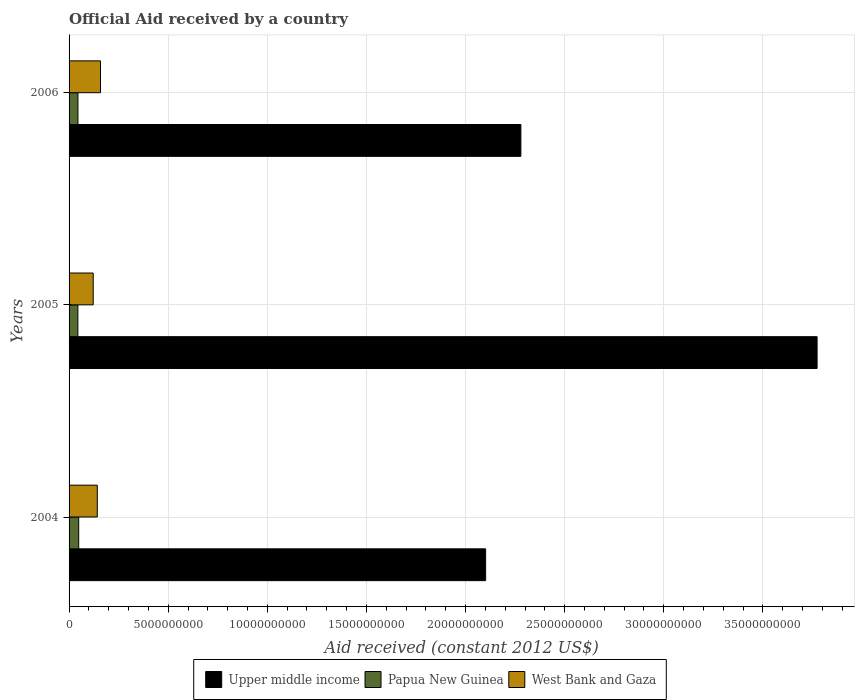How many groups of bars are there?
Your response must be concise. 3. Are the number of bars on each tick of the Y-axis equal?
Keep it short and to the point. Yes. How many bars are there on the 3rd tick from the bottom?
Ensure brevity in your answer.  3. What is the label of the 1st group of bars from the top?
Offer a very short reply. 2006. What is the net official aid received in Upper middle income in 2006?
Provide a succinct answer. 2.28e+1. Across all years, what is the maximum net official aid received in West Bank and Gaza?
Your answer should be very brief. 1.59e+09. Across all years, what is the minimum net official aid received in Upper middle income?
Make the answer very short. 2.10e+1. In which year was the net official aid received in Papua New Guinea maximum?
Provide a succinct answer. 2004. In which year was the net official aid received in West Bank and Gaza minimum?
Keep it short and to the point. 2005. What is the total net official aid received in Papua New Guinea in the graph?
Your response must be concise. 1.38e+09. What is the difference between the net official aid received in Upper middle income in 2004 and that in 2005?
Offer a very short reply. -1.67e+1. What is the difference between the net official aid received in Papua New Guinea in 2006 and the net official aid received in Upper middle income in 2005?
Your answer should be compact. -3.73e+1. What is the average net official aid received in West Bank and Gaza per year?
Provide a short and direct response. 1.41e+09. In the year 2004, what is the difference between the net official aid received in West Bank and Gaza and net official aid received in Upper middle income?
Offer a very short reply. -1.96e+1. What is the ratio of the net official aid received in Papua New Guinea in 2004 to that in 2006?
Your answer should be very brief. 1.09. What is the difference between the highest and the second highest net official aid received in Papua New Guinea?
Provide a succinct answer. 3.92e+07. What is the difference between the highest and the lowest net official aid received in West Bank and Gaza?
Keep it short and to the point. 3.68e+08. Is the sum of the net official aid received in Upper middle income in 2004 and 2005 greater than the maximum net official aid received in Papua New Guinea across all years?
Provide a short and direct response. Yes. What does the 1st bar from the top in 2004 represents?
Offer a terse response. West Bank and Gaza. What does the 3rd bar from the bottom in 2004 represents?
Your response must be concise. West Bank and Gaza. Is it the case that in every year, the sum of the net official aid received in Upper middle income and net official aid received in West Bank and Gaza is greater than the net official aid received in Papua New Guinea?
Make the answer very short. Yes. How many bars are there?
Provide a short and direct response. 9. What is the difference between two consecutive major ticks on the X-axis?
Offer a very short reply. 5.00e+09. Does the graph contain any zero values?
Offer a very short reply. No. Does the graph contain grids?
Make the answer very short. Yes. Where does the legend appear in the graph?
Provide a succinct answer. Bottom center. What is the title of the graph?
Provide a succinct answer. Official Aid received by a country. What is the label or title of the X-axis?
Your answer should be compact. Aid received (constant 2012 US$). What is the label or title of the Y-axis?
Ensure brevity in your answer.  Years. What is the Aid received (constant 2012 US$) of Upper middle income in 2004?
Offer a very short reply. 2.10e+1. What is the Aid received (constant 2012 US$) in Papua New Guinea in 2004?
Your answer should be compact. 4.86e+08. What is the Aid received (constant 2012 US$) of West Bank and Gaza in 2004?
Keep it short and to the point. 1.42e+09. What is the Aid received (constant 2012 US$) in Upper middle income in 2005?
Offer a terse response. 3.77e+1. What is the Aid received (constant 2012 US$) of Papua New Guinea in 2005?
Keep it short and to the point. 4.44e+08. What is the Aid received (constant 2012 US$) in West Bank and Gaza in 2005?
Give a very brief answer. 1.22e+09. What is the Aid received (constant 2012 US$) in Upper middle income in 2006?
Give a very brief answer. 2.28e+1. What is the Aid received (constant 2012 US$) of Papua New Guinea in 2006?
Give a very brief answer. 4.47e+08. What is the Aid received (constant 2012 US$) of West Bank and Gaza in 2006?
Keep it short and to the point. 1.59e+09. Across all years, what is the maximum Aid received (constant 2012 US$) in Upper middle income?
Provide a succinct answer. 3.77e+1. Across all years, what is the maximum Aid received (constant 2012 US$) in Papua New Guinea?
Make the answer very short. 4.86e+08. Across all years, what is the maximum Aid received (constant 2012 US$) of West Bank and Gaza?
Your answer should be very brief. 1.59e+09. Across all years, what is the minimum Aid received (constant 2012 US$) of Upper middle income?
Offer a very short reply. 2.10e+1. Across all years, what is the minimum Aid received (constant 2012 US$) of Papua New Guinea?
Ensure brevity in your answer.  4.44e+08. Across all years, what is the minimum Aid received (constant 2012 US$) in West Bank and Gaza?
Ensure brevity in your answer.  1.22e+09. What is the total Aid received (constant 2012 US$) of Upper middle income in the graph?
Ensure brevity in your answer.  8.15e+1. What is the total Aid received (constant 2012 US$) in Papua New Guinea in the graph?
Make the answer very short. 1.38e+09. What is the total Aid received (constant 2012 US$) of West Bank and Gaza in the graph?
Keep it short and to the point. 4.23e+09. What is the difference between the Aid received (constant 2012 US$) of Upper middle income in 2004 and that in 2005?
Provide a short and direct response. -1.67e+1. What is the difference between the Aid received (constant 2012 US$) in Papua New Guinea in 2004 and that in 2005?
Your answer should be very brief. 4.25e+07. What is the difference between the Aid received (constant 2012 US$) of West Bank and Gaza in 2004 and that in 2005?
Give a very brief answer. 2.06e+08. What is the difference between the Aid received (constant 2012 US$) of Upper middle income in 2004 and that in 2006?
Offer a very short reply. -1.78e+09. What is the difference between the Aid received (constant 2012 US$) in Papua New Guinea in 2004 and that in 2006?
Give a very brief answer. 3.92e+07. What is the difference between the Aid received (constant 2012 US$) in West Bank and Gaza in 2004 and that in 2006?
Keep it short and to the point. -1.62e+08. What is the difference between the Aid received (constant 2012 US$) of Upper middle income in 2005 and that in 2006?
Provide a succinct answer. 1.49e+1. What is the difference between the Aid received (constant 2012 US$) in Papua New Guinea in 2005 and that in 2006?
Provide a succinct answer. -3.31e+06. What is the difference between the Aid received (constant 2012 US$) of West Bank and Gaza in 2005 and that in 2006?
Your answer should be compact. -3.68e+08. What is the difference between the Aid received (constant 2012 US$) of Upper middle income in 2004 and the Aid received (constant 2012 US$) of Papua New Guinea in 2005?
Your answer should be very brief. 2.06e+1. What is the difference between the Aid received (constant 2012 US$) in Upper middle income in 2004 and the Aid received (constant 2012 US$) in West Bank and Gaza in 2005?
Your response must be concise. 1.98e+1. What is the difference between the Aid received (constant 2012 US$) in Papua New Guinea in 2004 and the Aid received (constant 2012 US$) in West Bank and Gaza in 2005?
Ensure brevity in your answer.  -7.31e+08. What is the difference between the Aid received (constant 2012 US$) in Upper middle income in 2004 and the Aid received (constant 2012 US$) in Papua New Guinea in 2006?
Make the answer very short. 2.06e+1. What is the difference between the Aid received (constant 2012 US$) of Upper middle income in 2004 and the Aid received (constant 2012 US$) of West Bank and Gaza in 2006?
Provide a short and direct response. 1.94e+1. What is the difference between the Aid received (constant 2012 US$) of Papua New Guinea in 2004 and the Aid received (constant 2012 US$) of West Bank and Gaza in 2006?
Offer a terse response. -1.10e+09. What is the difference between the Aid received (constant 2012 US$) of Upper middle income in 2005 and the Aid received (constant 2012 US$) of Papua New Guinea in 2006?
Offer a very short reply. 3.73e+1. What is the difference between the Aid received (constant 2012 US$) in Upper middle income in 2005 and the Aid received (constant 2012 US$) in West Bank and Gaza in 2006?
Your answer should be compact. 3.61e+1. What is the difference between the Aid received (constant 2012 US$) of Papua New Guinea in 2005 and the Aid received (constant 2012 US$) of West Bank and Gaza in 2006?
Make the answer very short. -1.14e+09. What is the average Aid received (constant 2012 US$) of Upper middle income per year?
Keep it short and to the point. 2.72e+1. What is the average Aid received (constant 2012 US$) in Papua New Guinea per year?
Provide a short and direct response. 4.59e+08. What is the average Aid received (constant 2012 US$) of West Bank and Gaza per year?
Give a very brief answer. 1.41e+09. In the year 2004, what is the difference between the Aid received (constant 2012 US$) of Upper middle income and Aid received (constant 2012 US$) of Papua New Guinea?
Provide a short and direct response. 2.05e+1. In the year 2004, what is the difference between the Aid received (constant 2012 US$) of Upper middle income and Aid received (constant 2012 US$) of West Bank and Gaza?
Give a very brief answer. 1.96e+1. In the year 2004, what is the difference between the Aid received (constant 2012 US$) of Papua New Guinea and Aid received (constant 2012 US$) of West Bank and Gaza?
Provide a succinct answer. -9.37e+08. In the year 2005, what is the difference between the Aid received (constant 2012 US$) of Upper middle income and Aid received (constant 2012 US$) of Papua New Guinea?
Give a very brief answer. 3.73e+1. In the year 2005, what is the difference between the Aid received (constant 2012 US$) of Upper middle income and Aid received (constant 2012 US$) of West Bank and Gaza?
Make the answer very short. 3.65e+1. In the year 2005, what is the difference between the Aid received (constant 2012 US$) in Papua New Guinea and Aid received (constant 2012 US$) in West Bank and Gaza?
Your answer should be compact. -7.74e+08. In the year 2006, what is the difference between the Aid received (constant 2012 US$) of Upper middle income and Aid received (constant 2012 US$) of Papua New Guinea?
Your answer should be very brief. 2.23e+1. In the year 2006, what is the difference between the Aid received (constant 2012 US$) in Upper middle income and Aid received (constant 2012 US$) in West Bank and Gaza?
Your answer should be very brief. 2.12e+1. In the year 2006, what is the difference between the Aid received (constant 2012 US$) in Papua New Guinea and Aid received (constant 2012 US$) in West Bank and Gaza?
Your response must be concise. -1.14e+09. What is the ratio of the Aid received (constant 2012 US$) of Upper middle income in 2004 to that in 2005?
Your answer should be compact. 0.56. What is the ratio of the Aid received (constant 2012 US$) in Papua New Guinea in 2004 to that in 2005?
Give a very brief answer. 1.1. What is the ratio of the Aid received (constant 2012 US$) in West Bank and Gaza in 2004 to that in 2005?
Ensure brevity in your answer.  1.17. What is the ratio of the Aid received (constant 2012 US$) of Upper middle income in 2004 to that in 2006?
Provide a short and direct response. 0.92. What is the ratio of the Aid received (constant 2012 US$) of Papua New Guinea in 2004 to that in 2006?
Ensure brevity in your answer.  1.09. What is the ratio of the Aid received (constant 2012 US$) of West Bank and Gaza in 2004 to that in 2006?
Make the answer very short. 0.9. What is the ratio of the Aid received (constant 2012 US$) in Upper middle income in 2005 to that in 2006?
Your answer should be compact. 1.66. What is the ratio of the Aid received (constant 2012 US$) of West Bank and Gaza in 2005 to that in 2006?
Provide a short and direct response. 0.77. What is the difference between the highest and the second highest Aid received (constant 2012 US$) in Upper middle income?
Your answer should be compact. 1.49e+1. What is the difference between the highest and the second highest Aid received (constant 2012 US$) in Papua New Guinea?
Make the answer very short. 3.92e+07. What is the difference between the highest and the second highest Aid received (constant 2012 US$) in West Bank and Gaza?
Keep it short and to the point. 1.62e+08. What is the difference between the highest and the lowest Aid received (constant 2012 US$) of Upper middle income?
Give a very brief answer. 1.67e+1. What is the difference between the highest and the lowest Aid received (constant 2012 US$) in Papua New Guinea?
Offer a terse response. 4.25e+07. What is the difference between the highest and the lowest Aid received (constant 2012 US$) of West Bank and Gaza?
Your answer should be very brief. 3.68e+08. 